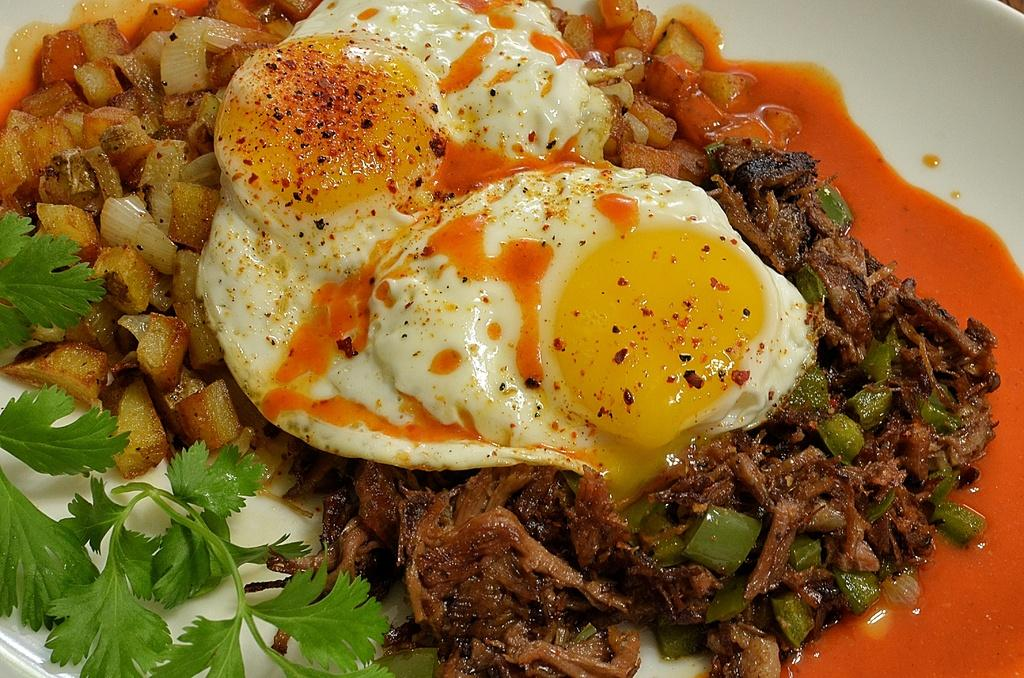What object is visible in the image that might be used for serving food? There is a plate in the image. What can be found on the plate? There are food items present on the plate. What type of vessel is used to hold the quartz on the plate? There is no quartz present on the plate, and therefore no vessel is needed to hold it. How does the wrist interact with the food items on the plate? The wrist is not visible in the image, and therefore it cannot be determined how it interacts with the food items on the plate. 